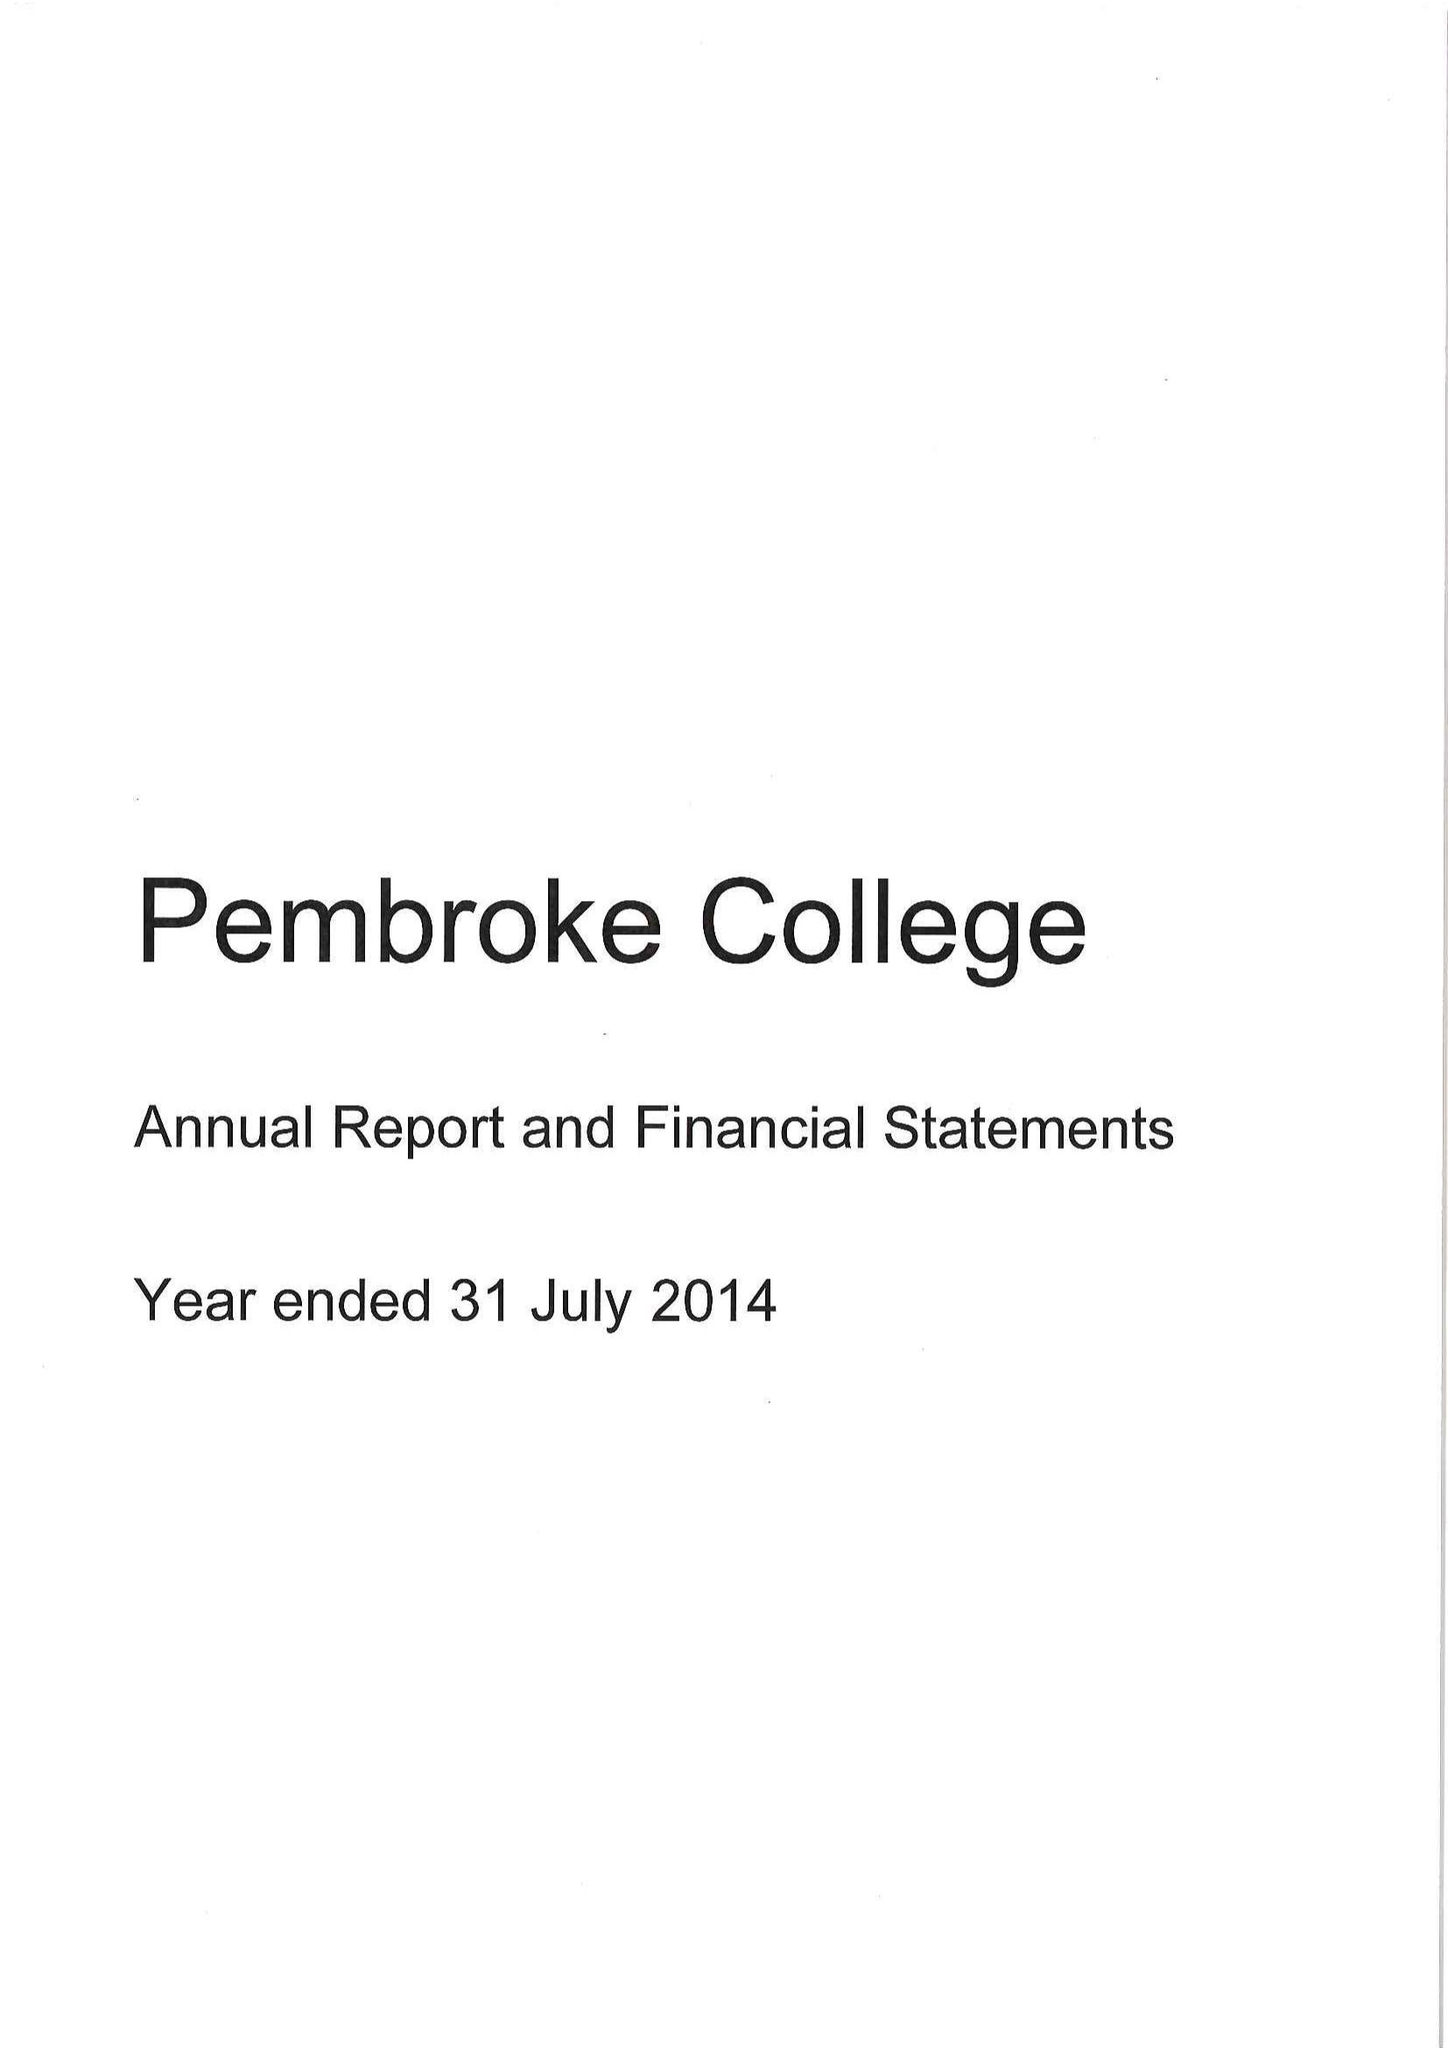What is the value for the address__post_town?
Answer the question using a single word or phrase. OXFORD 